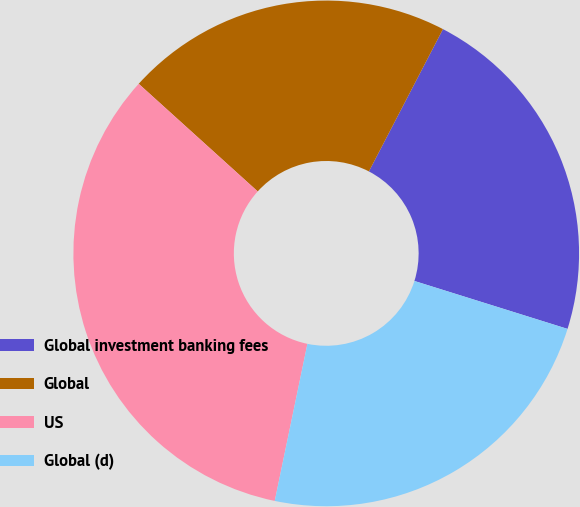Convert chart to OTSL. <chart><loc_0><loc_0><loc_500><loc_500><pie_chart><fcel>Global investment banking fees<fcel>Global<fcel>US<fcel>Global (d)<nl><fcel>22.19%<fcel>20.94%<fcel>33.44%<fcel>23.44%<nl></chart> 